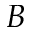Convert formula to latex. <formula><loc_0><loc_0><loc_500><loc_500>B</formula> 